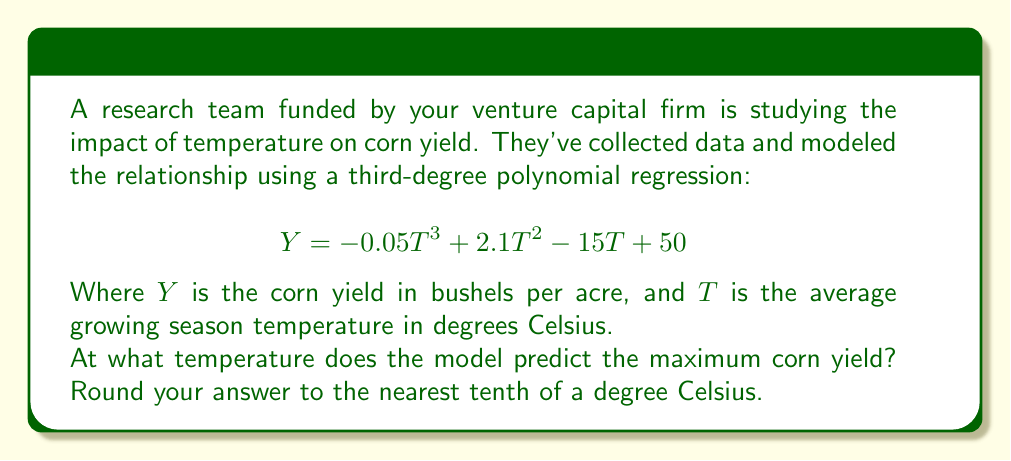Could you help me with this problem? To find the temperature that maximizes corn yield, we need to find the maximum point of the polynomial function. This occurs where the derivative of the function equals zero.

1) First, let's find the derivative of the yield function:

   $$\frac{dY}{dT} = -0.15T^2 + 4.2T - 15$$

2) Set the derivative equal to zero:

   $$-0.15T^2 + 4.2T - 15 = 0$$

3) This is a quadratic equation. We can solve it using the quadratic formula:

   $$T = \frac{-b \pm \sqrt{b^2 - 4ac}}{2a}$$

   Where $a = -0.15$, $b = 4.2$, and $c = -15$

4) Substituting these values:

   $$T = \frac{-4.2 \pm \sqrt{4.2^2 - 4(-0.15)(-15)}}{2(-0.15)}$$

5) Simplifying:

   $$T = \frac{-4.2 \pm \sqrt{17.64 - 9}}{-0.3} = \frac{-4.2 \pm \sqrt{8.64}}{-0.3} = \frac{-4.2 \pm 2.94}{-0.3}$$

6) This gives us two solutions:

   $$T_1 = \frac{-4.2 + 2.94}{-0.3} = 4.2$$
   $$T_2 = \frac{-4.2 - 2.94}{-0.3} = 23.8$$

7) To determine which of these is the maximum (rather than the minimum), we can check the second derivative:

   $$\frac{d^2Y}{dT^2} = -0.3T + 4.2$$

   At $T = 23.8$, this is negative, indicating a maximum.

8) Rounding to the nearest tenth:

   $23.8°C$
Answer: 23.8°C 